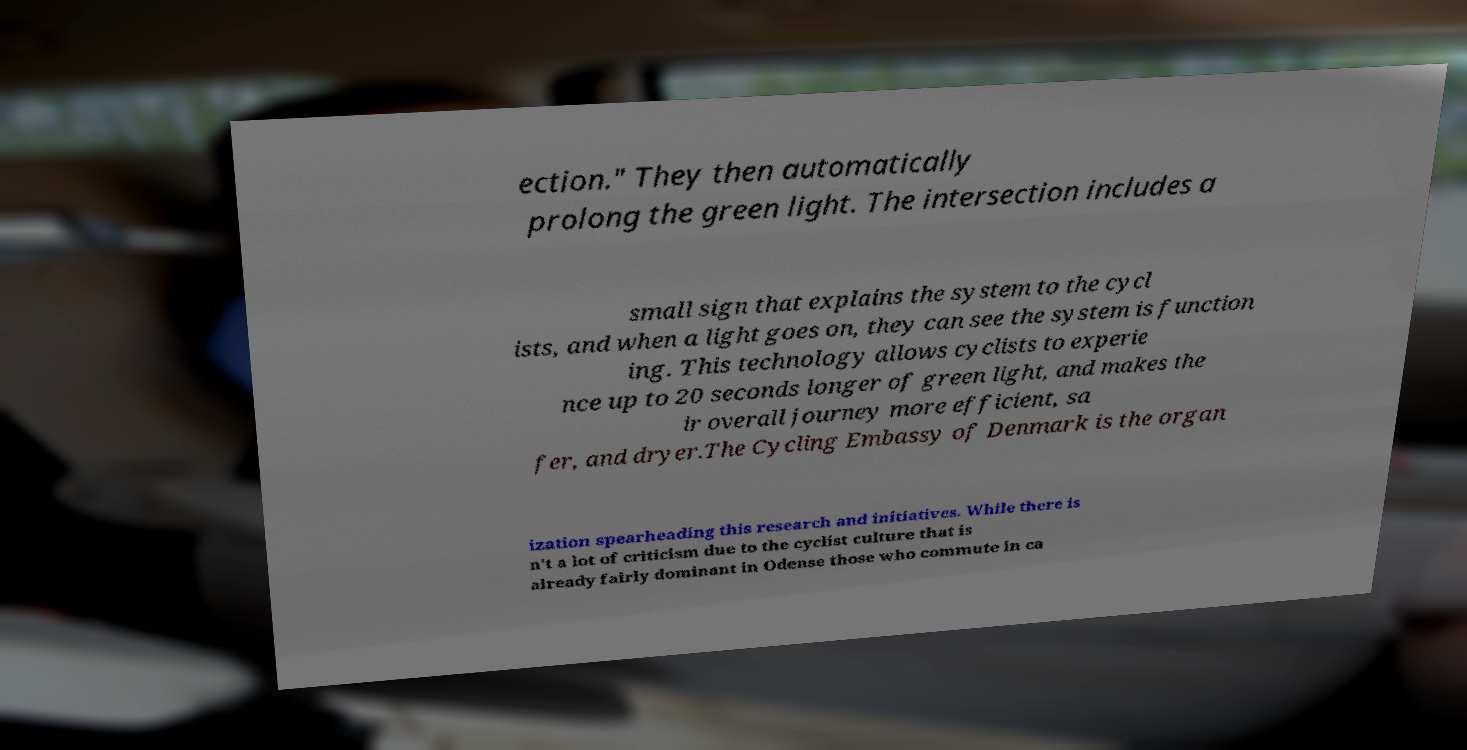There's text embedded in this image that I need extracted. Can you transcribe it verbatim? ection." They then automatically prolong the green light. The intersection includes a small sign that explains the system to the cycl ists, and when a light goes on, they can see the system is function ing. This technology allows cyclists to experie nce up to 20 seconds longer of green light, and makes the ir overall journey more efficient, sa fer, and dryer.The Cycling Embassy of Denmark is the organ ization spearheading this research and initiatives. While there is n't a lot of criticism due to the cyclist culture that is already fairly dominant in Odense those who commute in ca 